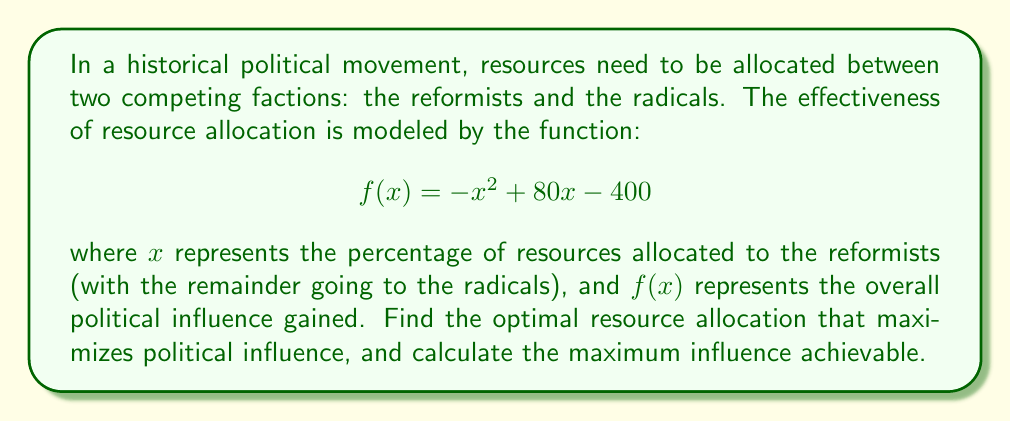Teach me how to tackle this problem. To solve this optimization problem, we need to find the maximum value of the quadratic function $f(x) = -x^2 + 80x - 400$. This can be done using calculus:

1. Find the derivative of $f(x)$:
   $$f'(x) = -2x + 80$$

2. Set the derivative equal to zero to find the critical point:
   $$-2x + 80 = 0$$
   $$-2x = -80$$
   $$x = 40$$

3. Verify this is a maximum by checking the second derivative:
   $$f''(x) = -2$$
   Since $f''(x)$ is negative, the critical point is a maximum.

4. Calculate the maximum influence by plugging $x = 40$ into the original function:
   $$f(40) = -(40)^2 + 80(40) - 400$$
   $$= -1600 + 3200 - 400$$
   $$= 1200$$

5. Interpret the results:
   The optimal resource allocation is 40% to the reformists and 60% to the radicals.
   The maximum political influence achievable is 1200 units.
Answer: The optimal resource allocation is 40% to the reformists and 60% to the radicals, resulting in a maximum political influence of 1200 units. 